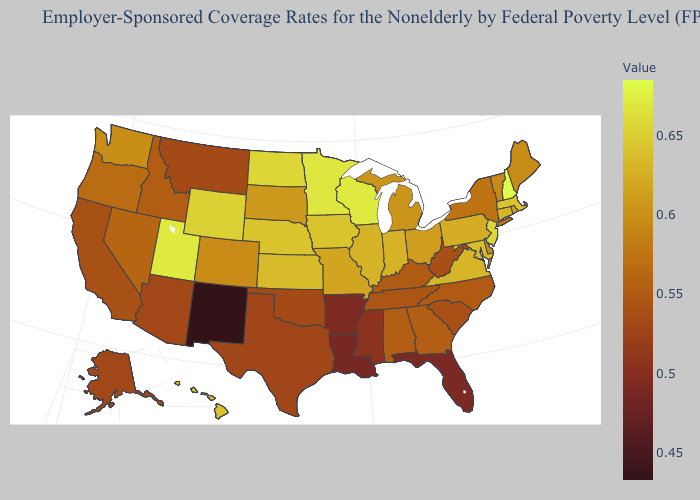Does Nevada have a lower value than Illinois?
Write a very short answer. Yes. Does South Dakota have the highest value in the MidWest?
Short answer required. No. Among the states that border Georgia , which have the highest value?
Be succinct. Alabama. Does Iowa have the lowest value in the MidWest?
Short answer required. No. 